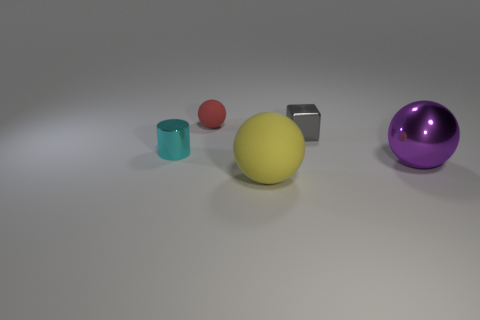Is the object left of the red ball made of the same material as the yellow thing?
Make the answer very short. No. Does the thing that is on the left side of the red object have the same material as the sphere that is to the left of the big yellow object?
Offer a very short reply. No. Is the number of objects that are to the left of the metal cube greater than the number of big blue matte balls?
Your answer should be very brief. Yes. There is a ball that is behind the metal thing on the left side of the gray metal object; what is its color?
Offer a very short reply. Red. What shape is the shiny object that is the same size as the gray metallic block?
Provide a succinct answer. Cylinder. Are there the same number of blocks in front of the yellow sphere and large purple metal objects?
Offer a terse response. No. What material is the small object right of the rubber thing in front of the tiny metallic object in front of the tiny gray object?
Offer a terse response. Metal. There is a large purple object that is made of the same material as the cylinder; what shape is it?
Provide a succinct answer. Sphere. Are there any other things that have the same color as the big metal object?
Your answer should be very brief. No. How many small red matte objects are in front of the tiny metal thing left of the small red rubber thing that is behind the small gray thing?
Keep it short and to the point. 0. 